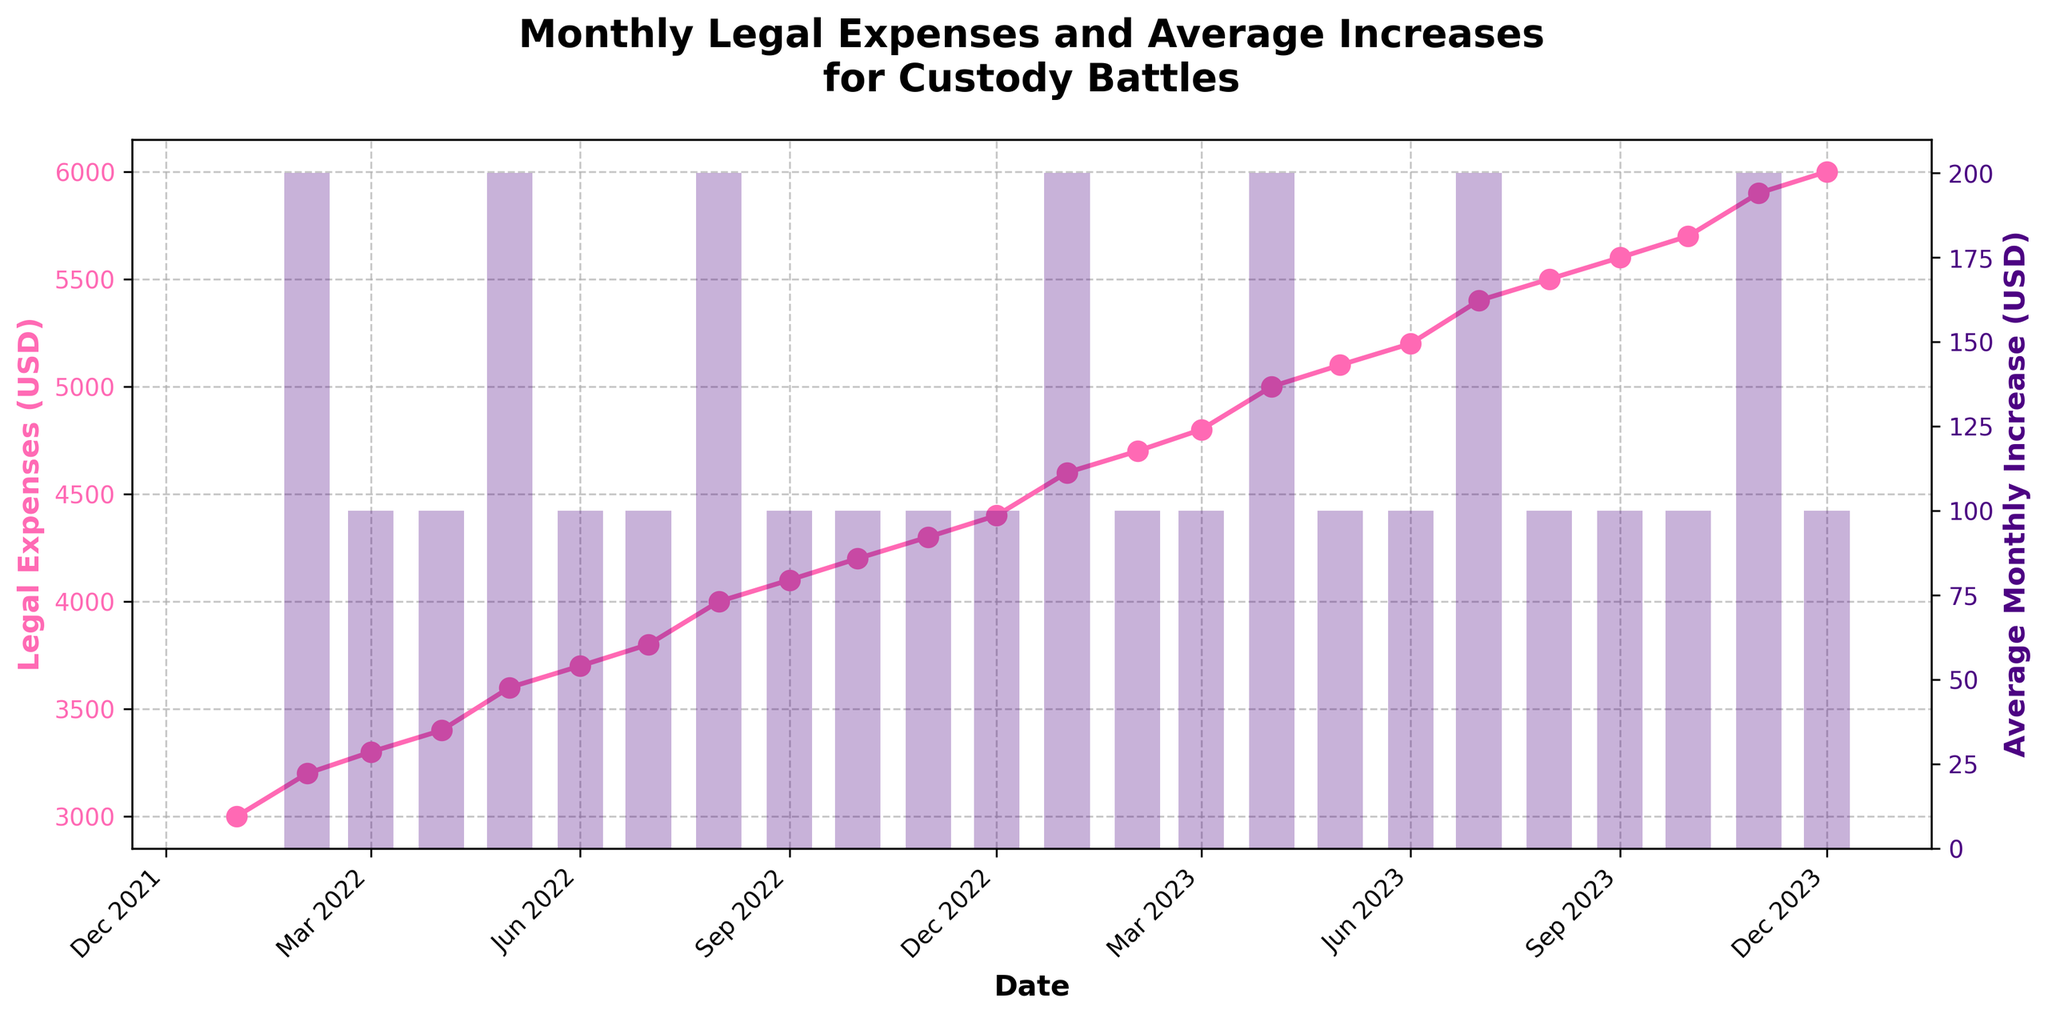What is the title of the plot? The title of the plot is located at the top center of the figure. It summarizes the content of the plot, indicating that it shows data on monthly legal expenses and their average increases for custody battles.
Answer: Monthly Legal Expenses and Average Increases for Custody Battles Which month had the highest legal expenses? The highest point on the Legal Expenses (USD) line will indicate the month with the highest expenses. By checking the end of the plot, the highest point is in December 2023.
Answer: December 2023 How did the legal expenses change from January 2022 to December 2023? Start by identifying the values of legal expenses for January 2022 and December 2023. January 2022 had legal expenses of $3,000 and December 2023 had legal expenses of $6,000. Calculate the difference to find the increase.
Answer: Increased by $3,000 What was the average monthly increase in legal expenses for April 2022? The average monthly increase for each month is indicated by the height of the bar for that month. For April 2022, there is a bar marked at $100.
Answer: $100 Compare the legal expenses in January 2022 and January 2023. By how much did they increase? Identify the legal expenses for January 2022 and January 2023 from the plot, which are $3,000 and $4,600 respectively. The increase can be calculated as $4,600 - $3,000.
Answer: $1,600 During which months did the legal expenses increase by $200? The bars with a height of $200 indicate the months with this average monthly increase. According to the plot, these months are February 2022, May 2022, August 2022, January 2023, April 2023, July 2023, and November 2023.
Answer: February 2022, May 2022, August 2022, January 2023, April 2023, July 2023, November 2023 What trend is noticeable in the duration of your legal expenses from July 2022 to December 2023? Observing the plot's line from July 2022 to December 2023, it shows a general increasing trend over time with occasional increases in the rate (indicated by a steeper slope) in particular months.
Answer: Increasing trend How frequently do the legal expenses increase by $200 as opposed to $100? Examine the number of months with $200 increases compared to $100 increases by counting the respective bars. The plot shows there are more months with $100 increases than with $200 increases.
Answer: More frequent increases of $100 What is the total increase in legal expenses over the whole period shown in the plot? Compute the difference between the maximum value (December 2023 with $6,000) and the minimum value (January 2022 with $3,000). The total increase is $6,000 - $3,000.
Answer: $3,000 